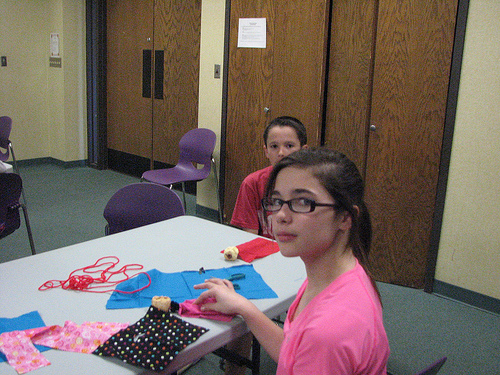<image>
Is there a girl in front of the cloth? Yes. The girl is positioned in front of the cloth, appearing closer to the camera viewpoint. 